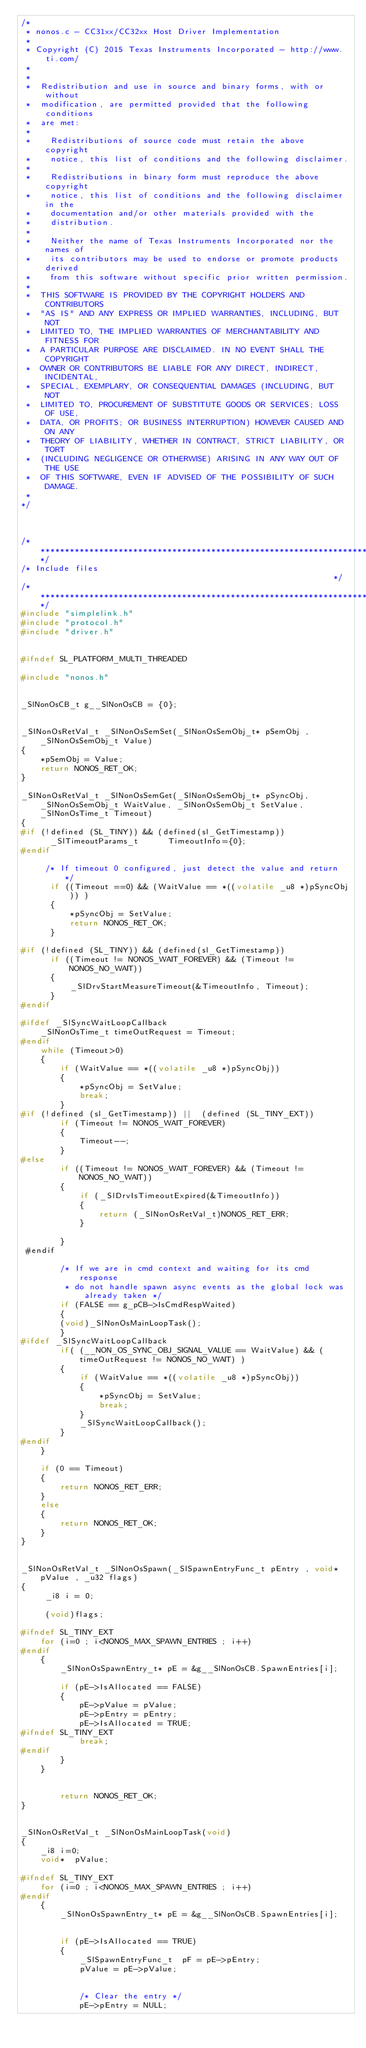<code> <loc_0><loc_0><loc_500><loc_500><_C_>/*
 * nonos.c - CC31xx/CC32xx Host Driver Implementation
 *
 * Copyright (C) 2015 Texas Instruments Incorporated - http://www.ti.com/ 
 * 
 * 
 *  Redistribution and use in source and binary forms, with or without 
 *  modification, are permitted provided that the following conditions 
 *  are met:
 *
 *    Redistributions of source code must retain the above copyright 
 *    notice, this list of conditions and the following disclaimer.
 *
 *    Redistributions in binary form must reproduce the above copyright
 *    notice, this list of conditions and the following disclaimer in the 
 *    documentation and/or other materials provided with the   
 *    distribution.
 *
 *    Neither the name of Texas Instruments Incorporated nor the names of
 *    its contributors may be used to endorse or promote products derived
 *    from this software without specific prior written permission.
 *
 *  THIS SOFTWARE IS PROVIDED BY THE COPYRIGHT HOLDERS AND CONTRIBUTORS 
 *  "AS IS" AND ANY EXPRESS OR IMPLIED WARRANTIES, INCLUDING, BUT NOT 
 *  LIMITED TO, THE IMPLIED WARRANTIES OF MERCHANTABILITY AND FITNESS FOR
 *  A PARTICULAR PURPOSE ARE DISCLAIMED. IN NO EVENT SHALL THE COPYRIGHT 
 *  OWNER OR CONTRIBUTORS BE LIABLE FOR ANY DIRECT, INDIRECT, INCIDENTAL, 
 *  SPECIAL, EXEMPLARY, OR CONSEQUENTIAL DAMAGES (INCLUDING, BUT NOT 
 *  LIMITED TO, PROCUREMENT OF SUBSTITUTE GOODS OR SERVICES; LOSS OF USE,
 *  DATA, OR PROFITS; OR BUSINESS INTERRUPTION) HOWEVER CAUSED AND ON ANY
 *  THEORY OF LIABILITY, WHETHER IN CONTRACT, STRICT LIABILITY, OR TORT 
 *  (INCLUDING NEGLIGENCE OR OTHERWISE) ARISING IN ANY WAY OUT OF THE USE 
 *  OF THIS SOFTWARE, EVEN IF ADVISED OF THE POSSIBILITY OF SUCH DAMAGE.
 *
*/



/*****************************************************************************/
/* Include files                                                             */
/*****************************************************************************/
#include "simplelink.h"
#include "protocol.h"
#include "driver.h"


#ifndef SL_PLATFORM_MULTI_THREADED

#include "nonos.h"


_SlNonOsCB_t g__SlNonOsCB = {0};


_SlNonOsRetVal_t _SlNonOsSemSet(_SlNonOsSemObj_t* pSemObj , _SlNonOsSemObj_t Value)
{
    *pSemObj = Value;
    return NONOS_RET_OK;
}

_SlNonOsRetVal_t _SlNonOsSemGet(_SlNonOsSemObj_t* pSyncObj, _SlNonOsSemObj_t WaitValue, _SlNonOsSemObj_t SetValue, _SlNonOsTime_t Timeout)
{
#if (!defined (SL_TINY)) && (defined(sl_GetTimestamp))
      _SlTimeoutParams_t      TimeoutInfo={0};
#endif

	 /* If timeout 0 configured, just detect the value and return */
      if ((Timeout ==0) && (WaitValue == *((volatile _u8 *)pSyncObj)) )
	  {
		  *pSyncObj = SetValue;
		  return NONOS_RET_OK;
	  }

#if (!defined (SL_TINY)) && (defined(sl_GetTimestamp))
      if ((Timeout != NONOS_WAIT_FOREVER) && (Timeout != NONOS_NO_WAIT))
      {
    	  _SlDrvStartMeasureTimeout(&TimeoutInfo, Timeout);
      }
#endif

#ifdef _SlSyncWaitLoopCallback
    _SlNonOsTime_t timeOutRequest = Timeout; 
#endif
    while (Timeout>0)
    {
        if (WaitValue == *((volatile _u8 *)pSyncObj))
        {
            *pSyncObj = SetValue;
            break;
        }
#if (!defined (sl_GetTimestamp)) ||  (defined (SL_TINY_EXT))
        if (Timeout != NONOS_WAIT_FOREVER)
        {		
            Timeout--;
        }
#else        
        if ((Timeout != NONOS_WAIT_FOREVER) && (Timeout != NONOS_NO_WAIT))
        {
            if (_SlDrvIsTimeoutExpired(&TimeoutInfo))
            {
            	return (_SlNonOsRetVal_t)NONOS_RET_ERR;
            }

        }
 #endif       

        /* If we are in cmd context and waiting for its cmd response
         * do not handle spawn async events as the global lock was already taken */
        if (FALSE == g_pCB->IsCmdRespWaited)
        {
        (void)_SlNonOsMainLoopTask();
        }
#ifdef _SlSyncWaitLoopCallback
        if( (__NON_OS_SYNC_OBJ_SIGNAL_VALUE == WaitValue) && (timeOutRequest != NONOS_NO_WAIT) )
        {
            if (WaitValue == *((volatile _u8 *)pSyncObj))
            {
                *pSyncObj = SetValue;
                break;
            }
            _SlSyncWaitLoopCallback();
        }
#endif
    }

    if (0 == Timeout)
    {
        return NONOS_RET_ERR;
    }
    else
    {
        return NONOS_RET_OK;
    }
}


_SlNonOsRetVal_t _SlNonOsSpawn(_SlSpawnEntryFunc_t pEntry , void* pValue , _u32 flags)
{
	 _i8 i = 0;

     (void)flags;
    
#ifndef SL_TINY_EXT 	
	for (i=0 ; i<NONOS_MAX_SPAWN_ENTRIES ; i++)
#endif     
	{
		_SlNonOsSpawnEntry_t* pE = &g__SlNonOsCB.SpawnEntries[i];
	
		if (pE->IsAllocated == FALSE)
		{
			pE->pValue = pValue;
			pE->pEntry = pEntry;
			pE->IsAllocated = TRUE;
#ifndef SL_TINY_EXT 	                        
			break;
#endif                        
		}
	}
        
        
        return NONOS_RET_OK;
}


_SlNonOsRetVal_t _SlNonOsMainLoopTask(void)
{
	_i8 i=0;
	void*  pValue;

#ifndef SL_TINY_EXT
	for (i=0 ; i<NONOS_MAX_SPAWN_ENTRIES ; i++)
#endif
	{
		_SlNonOsSpawnEntry_t* pE = &g__SlNonOsCB.SpawnEntries[i];
		

		if (pE->IsAllocated == TRUE)
		{
			_SlSpawnEntryFunc_t  pF = pE->pEntry;
			pValue = pE->pValue;


			/* Clear the entry */
			pE->pEntry = NULL;</code> 